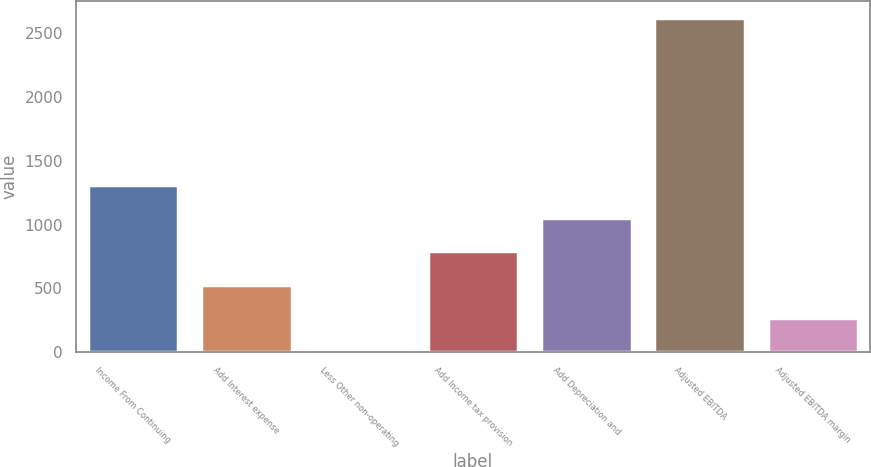Convert chart to OTSL. <chart><loc_0><loc_0><loc_500><loc_500><bar_chart><fcel>Income From Continuing<fcel>Add Interest expense<fcel>Less Other non-operating<fcel>Add Income tax provision<fcel>Add Depreciation and<fcel>Adjusted EBITDA<fcel>Adjusted EBITDA margin<nl><fcel>1313.6<fcel>528.68<fcel>5.4<fcel>790.32<fcel>1051.96<fcel>2621.8<fcel>267.04<nl></chart> 